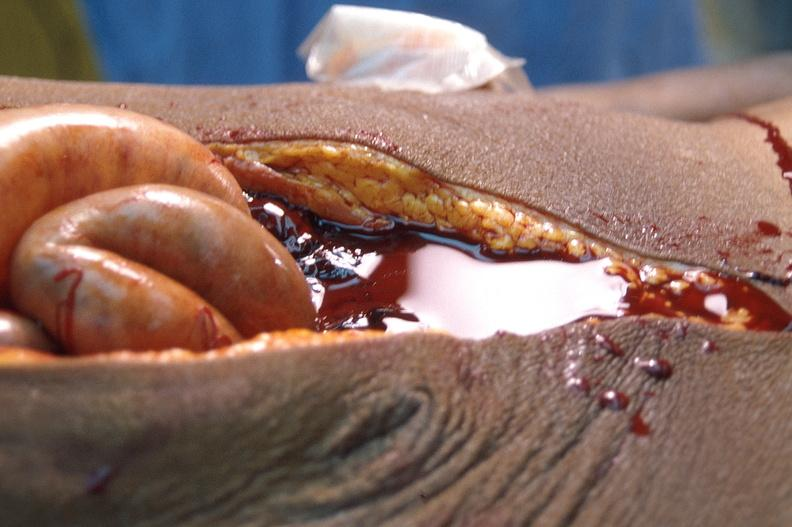where is this area in the body?
Answer the question using a single word or phrase. Abdomen 